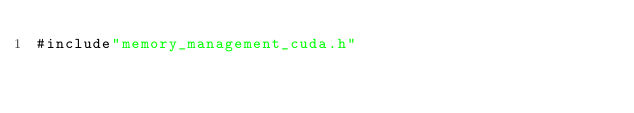<code> <loc_0><loc_0><loc_500><loc_500><_Cuda_>#include"memory_management_cuda.h"



</code> 